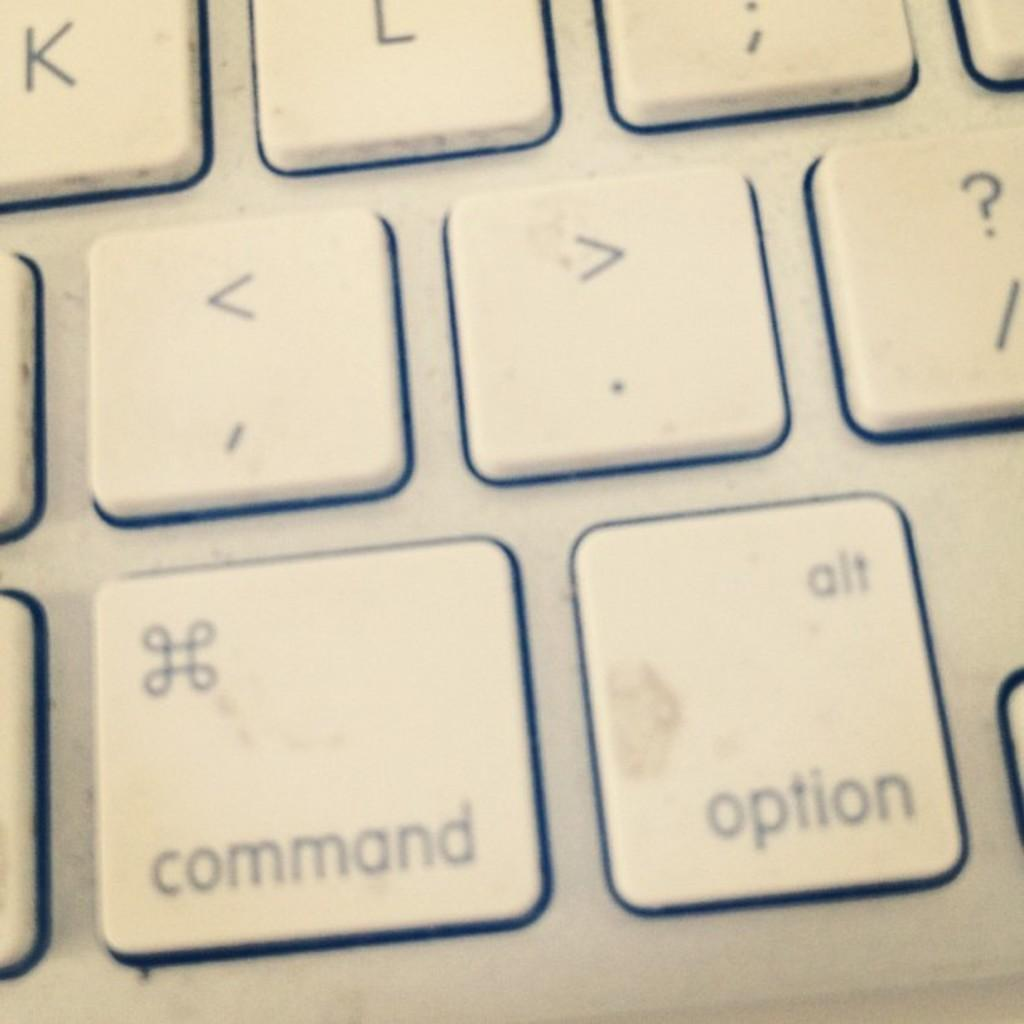<image>
Provide a brief description of the given image. A zoomed in keyboard with the command and option keys prominent. 